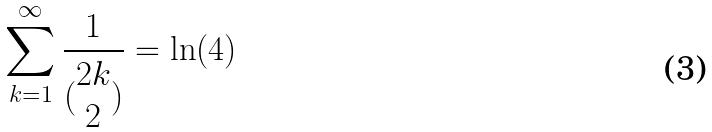Convert formula to latex. <formula><loc_0><loc_0><loc_500><loc_500>\sum _ { k = 1 } ^ { \infty } \frac { 1 } { ( \begin{matrix} 2 k \\ 2 \end{matrix} ) } = \ln ( 4 )</formula> 